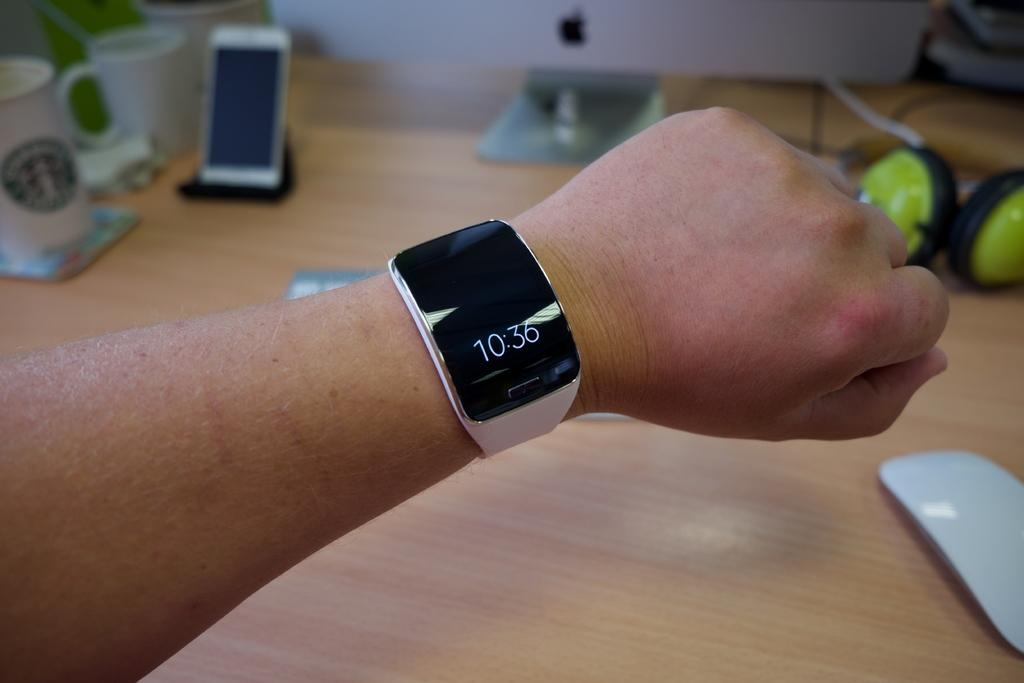Provide a one-sentence caption for the provided image. A watch, bearing the time of 10:36, is on someone's arm. 